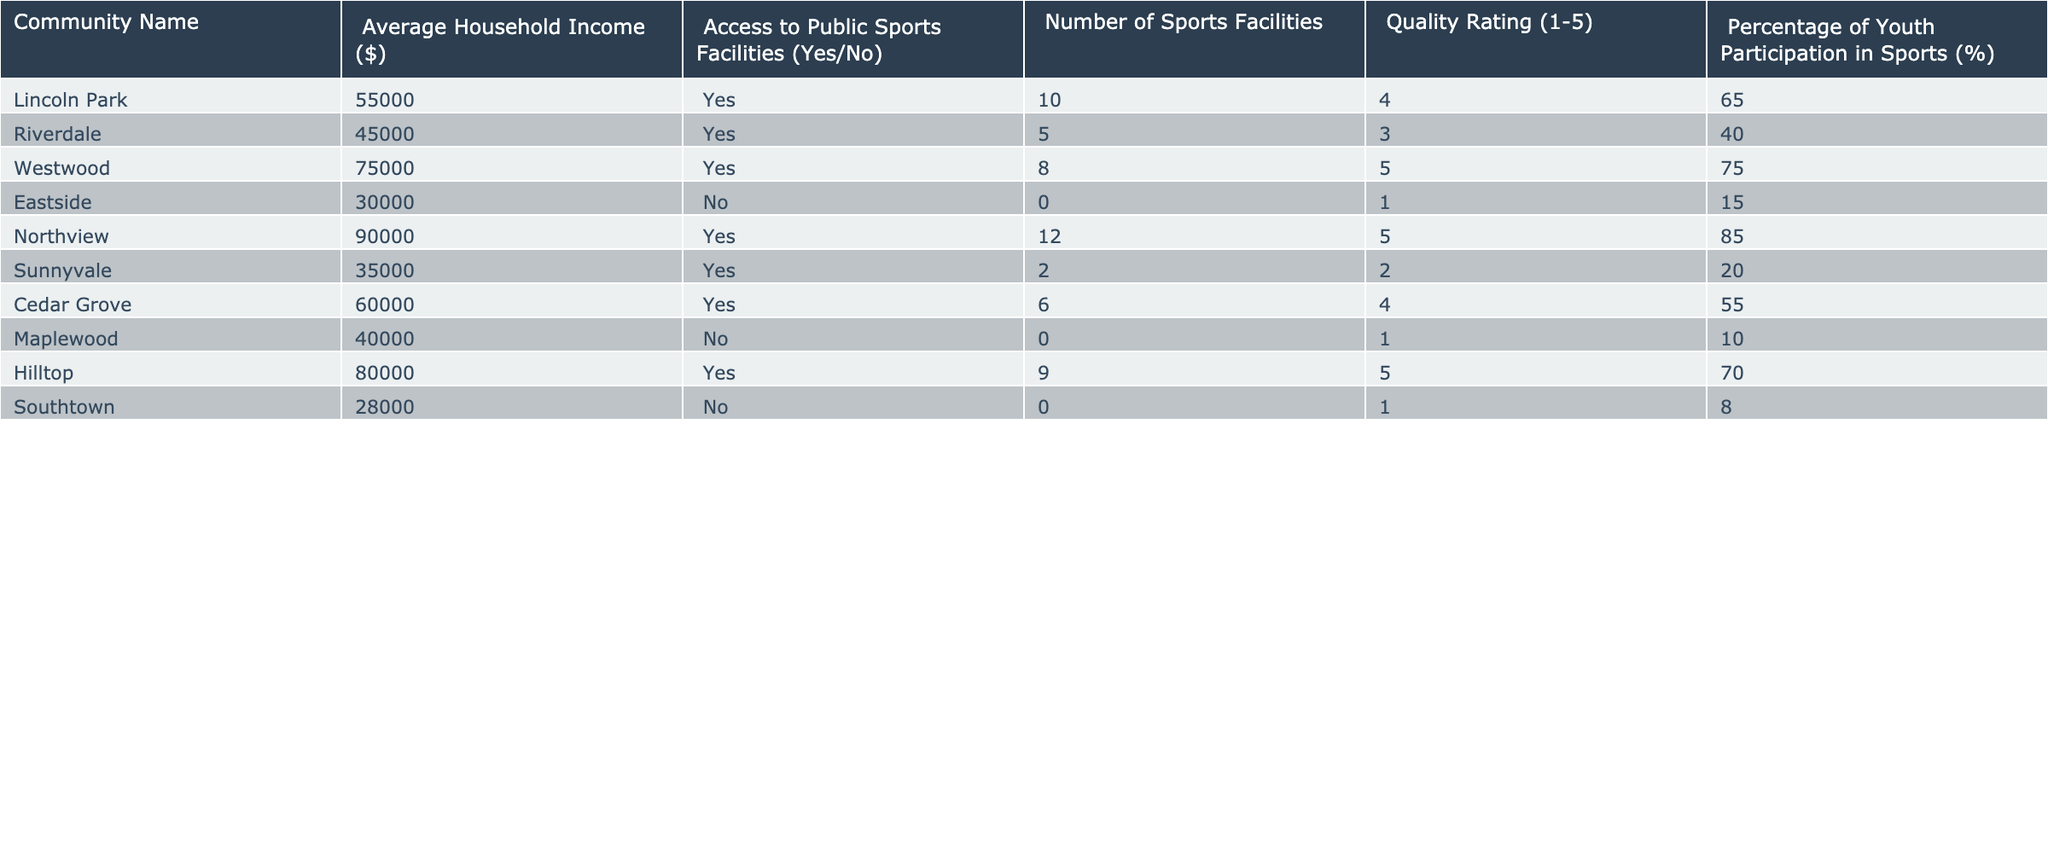What is the average household income of the communities that have access to public sports facilities? Review the "Average Household Income" for communities with "Access to Public Sports Facilities" marked as "Yes." The communities are Lincoln Park ($55,000), Riverdale ($45,000), Westwood ($75,000), Northview ($90,000), Cedar Grove ($60,000), Hilltop ($80,000). The sum is $55,000 + $45,000 + $75,000 + $90,000 + $60,000 + $80,000 = $405,000. There are 6 communities, so the average is $405,000 / 6 = $67,500.
Answer: 67,500 Which community has the highest quality rating for its sports facilities? Look for the maximum value in the "Quality Rating" column across all communities. The highest rating is 5, which occurs in Westwood, Northview, and Hilltop. Therefore, they share the highest quality rating.
Answer: Westwood, Northview, and Hilltop Is there a community with a high percentage of youth participation in sports but low access to facilities? Assess the "Percentage of Youth Participation in Sports" and the "Access to Public Sports Facilities" together. Eastside (15%) and Southtown (8%) have no access to facilities. Both communities show low youth participation, indicating no communities with high youth participation and low access in this data.
Answer: No What is the total number of sports facilities available in communities with an average household income above $60,000? Identify communities with an "Average Household Income" higher than $60,000, which includes Westwood ($75,000), Northview ($90,000), and Hilltop ($80,000). The total facilities are 8 + 12 + 9 = 29.
Answer: 29 Are there any communities with access to public sports facilities that have less than 30% youth participation? Examine the "Percentage of Youth Participation in Sports" for each community with "Access to Public Sports Facilities." Lincoln Park (65%) and Cedar Grove (55%) both have more than 30%. Riverdale (40%) also meets this criterion. Thus, all communities with access show participation above 30%.
Answer: No Which community has the lowest average household income, and what is its access status to sports facilities? Identify the lowest "Average Household Income." Eastside has the lowest income at $30,000. Check the access status: it is marked "No."
Answer: Eastside; No What is the difference in quality ratings between the community with the highest and the lowest rating? Determine the highest (5) and lowest (1) quality ratings from the table. Compute the difference: 5 - 1 = 4.
Answer: 4 Which community has the highest percentage of youth participation and what is that percentage? Look at the "Percentage of Youth Participation in Sports." Northview has the highest at 85%.
Answer: 85% 